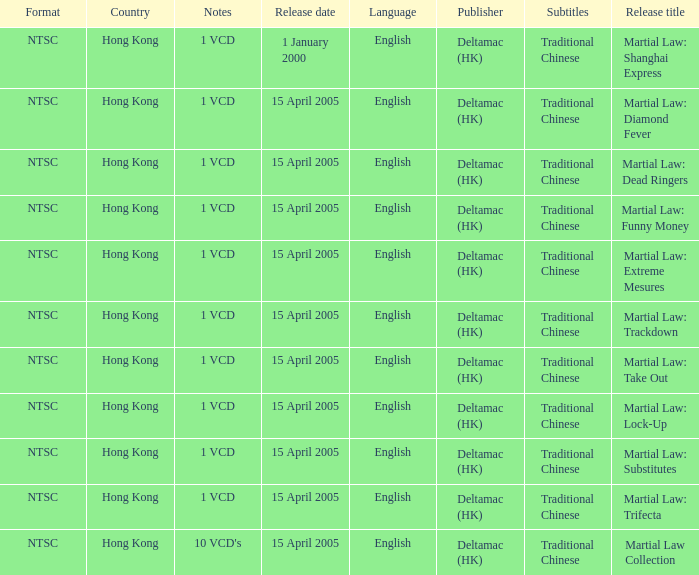What is the release date of Martial Law: Take Out? 15 April 2005. 